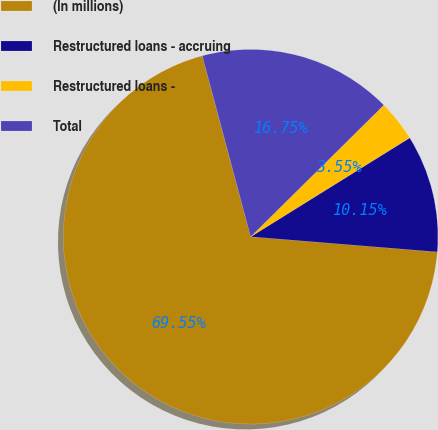<chart> <loc_0><loc_0><loc_500><loc_500><pie_chart><fcel>(In millions)<fcel>Restructured loans - accruing<fcel>Restructured loans -<fcel>Total<nl><fcel>69.54%<fcel>10.15%<fcel>3.55%<fcel>16.75%<nl></chart> 